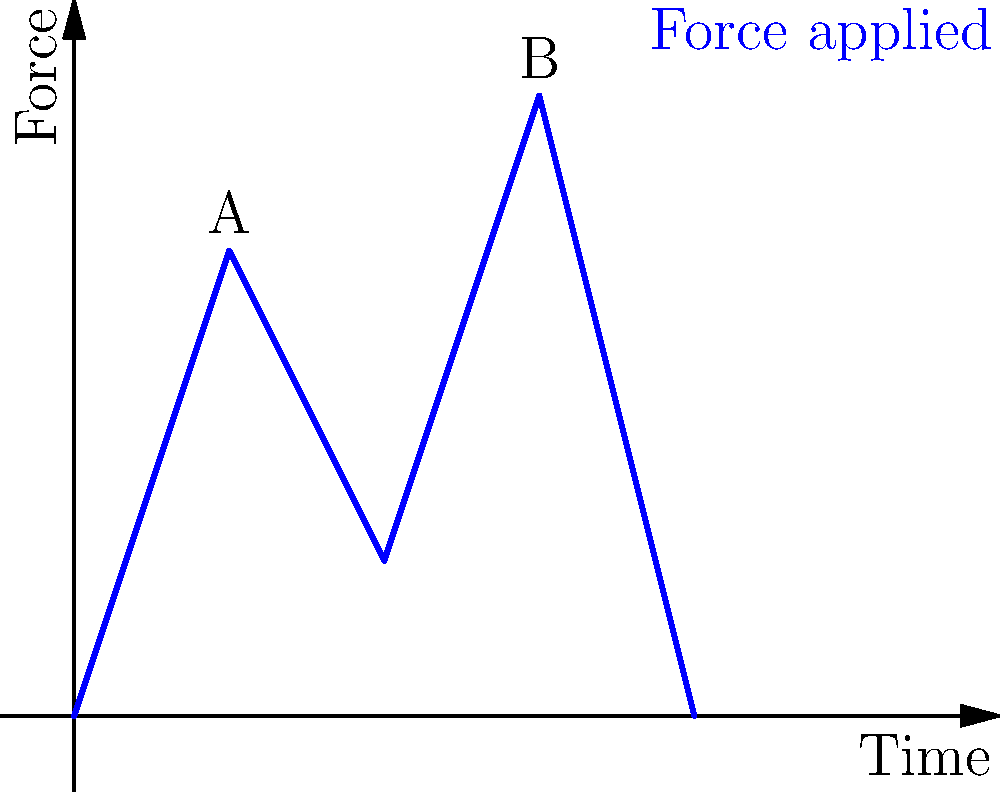In social dancing, the lead often applies varying forces to guide their partner. The graph shows the force applied by a lead over time during a dance move. Which point on the curve represents the optimal moment for the follow to execute a spin, assuming that a higher force provides a clearer signal for the spin? To determine the optimal moment for the follow to execute a spin, we need to analyze the force curve:

1. The graph shows the force applied by the lead over time during a dance move.
2. A higher force generally provides a clearer signal for the follow to respond to.
3. There are two notable peaks in the force curve:
   - Point A at time 0.5
   - Point B at time 1.5
4. Comparing the two peaks:
   - Point A reaches a force of about 1.5 units
   - Point B reaches a force of about 2 units
5. Since Point B represents a higher force, it would provide a clearer signal for the follow.
6. A clearer signal allows for better communication between partners, which is crucial in social dancing situations.
7. Therefore, Point B represents the optimal moment for the follow to execute a spin, as it corresponds to the highest force applied by the lead.

This understanding of force application in dance movements can help a single parent navigate social dancing situations more confidently when using a dating platform to meet new people.
Answer: Point B 